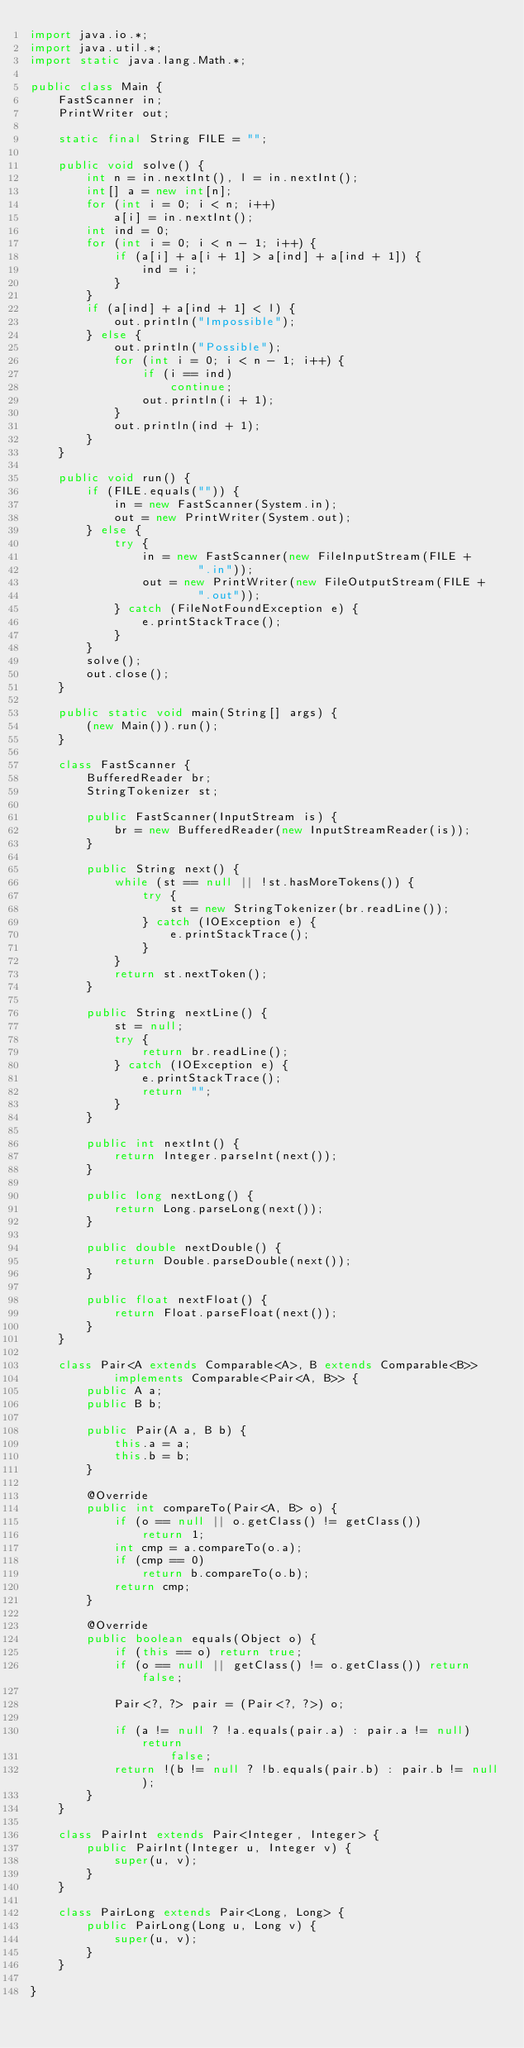Convert code to text. <code><loc_0><loc_0><loc_500><loc_500><_Java_>import java.io.*;
import java.util.*;
import static java.lang.Math.*;

public class Main {
    FastScanner in;
    PrintWriter out;

    static final String FILE = "";

    public void solve() {
        int n = in.nextInt(), l = in.nextInt();
        int[] a = new int[n];
        for (int i = 0; i < n; i++)
            a[i] = in.nextInt();
        int ind = 0;
        for (int i = 0; i < n - 1; i++) {
            if (a[i] + a[i + 1] > a[ind] + a[ind + 1]) {
                ind = i;
            }
        }
        if (a[ind] + a[ind + 1] < l) {
            out.println("Impossible");
        } else {
            out.println("Possible");
            for (int i = 0; i < n - 1; i++) {
                if (i == ind)
                    continue;
                out.println(i + 1);
            }
            out.println(ind + 1);
        }
    }

    public void run() {
        if (FILE.equals("")) {
            in = new FastScanner(System.in);
            out = new PrintWriter(System.out);
        } else {
            try {
                in = new FastScanner(new FileInputStream(FILE +
                        ".in"));
                out = new PrintWriter(new FileOutputStream(FILE +
                        ".out"));
            } catch (FileNotFoundException e) {
                e.printStackTrace();
            }
        }
        solve();
        out.close();
    }

    public static void main(String[] args) {
        (new Main()).run();
    }

    class FastScanner {
        BufferedReader br;
        StringTokenizer st;

        public FastScanner(InputStream is) {
            br = new BufferedReader(new InputStreamReader(is));
        }

        public String next() {
            while (st == null || !st.hasMoreTokens()) {
                try {
                    st = new StringTokenizer(br.readLine());
                } catch (IOException e) {
                    e.printStackTrace();
                }
            }
            return st.nextToken();
        }

        public String nextLine() {
            st = null;
            try {
                return br.readLine();
            } catch (IOException e) {
                e.printStackTrace();
                return "";
            }
        }

        public int nextInt() {
            return Integer.parseInt(next());
        }

        public long nextLong() {
            return Long.parseLong(next());
        }

        public double nextDouble() {
            return Double.parseDouble(next());
        }

        public float nextFloat() {
            return Float.parseFloat(next());
        }
    }

    class Pair<A extends Comparable<A>, B extends Comparable<B>>
            implements Comparable<Pair<A, B>> {
        public A a;
        public B b;

        public Pair(A a, B b) {
            this.a = a;
            this.b = b;
        }

        @Override
        public int compareTo(Pair<A, B> o) {
            if (o == null || o.getClass() != getClass())
                return 1;
            int cmp = a.compareTo(o.a);
            if (cmp == 0)
                return b.compareTo(o.b);
            return cmp;
        }

        @Override
        public boolean equals(Object o) {
            if (this == o) return true;
            if (o == null || getClass() != o.getClass()) return false;

            Pair<?, ?> pair = (Pair<?, ?>) o;

            if (a != null ? !a.equals(pair.a) : pair.a != null) return
                    false;
            return !(b != null ? !b.equals(pair.b) : pair.b != null);
        }
    }

    class PairInt extends Pair<Integer, Integer> {
        public PairInt(Integer u, Integer v) {
            super(u, v);
        }
    }

    class PairLong extends Pair<Long, Long> {
        public PairLong(Long u, Long v) {
            super(u, v);
        }
    }

}</code> 